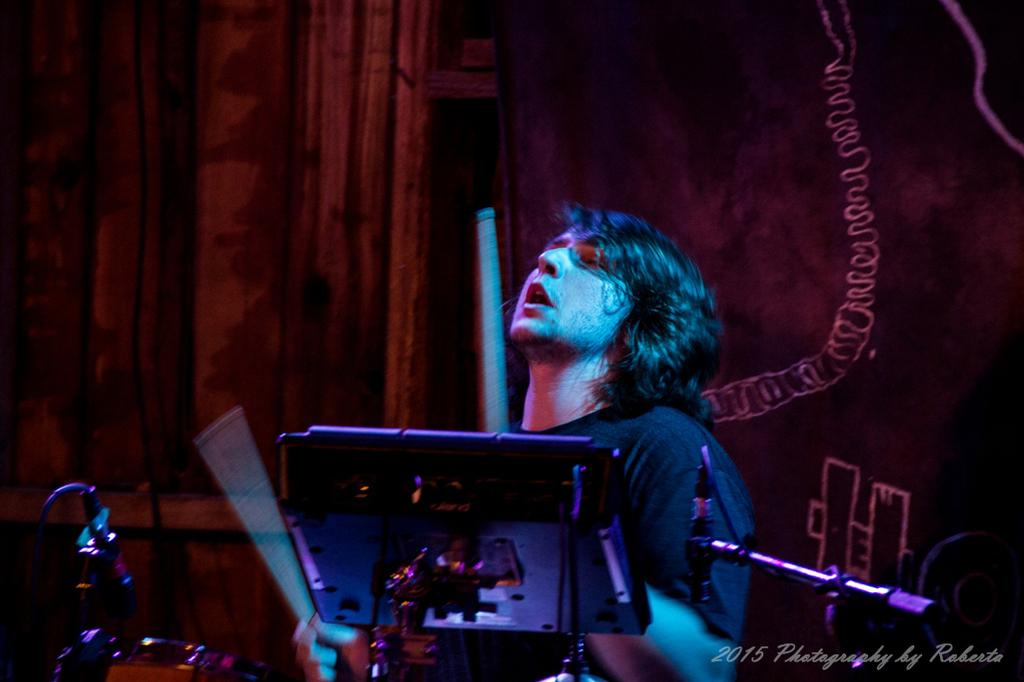What is the main subject in the foreground of the image? There is a man in the foreground of the image. What is the man holding in the image? The man is holding drum sticks. What is the man doing in the image? The man is playing musical instruments. What is in front of the man that might be used for amplifying sound? There are microphones in front of the man. What can be seen in the background of the image? In the background, there are curtains. What position does the giraffe hold in the band in the image? There is no giraffe present in the image; it is a man playing musical instruments. Can you tell me how many tickets are available for the concert in the image? There is no information about tickets or a concert in the image. 